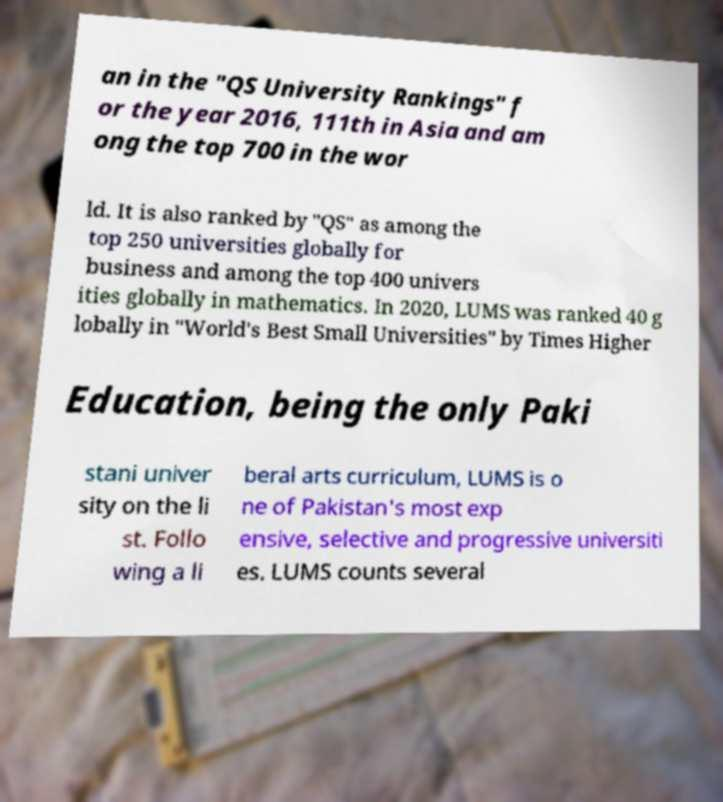What messages or text are displayed in this image? I need them in a readable, typed format. an in the "QS University Rankings" f or the year 2016, 111th in Asia and am ong the top 700 in the wor ld. It is also ranked by "QS" as among the top 250 universities globally for business and among the top 400 univers ities globally in mathematics. In 2020, LUMS was ranked 40 g lobally in "World's Best Small Universities" by Times Higher Education, being the only Paki stani univer sity on the li st. Follo wing a li beral arts curriculum, LUMS is o ne of Pakistan's most exp ensive, selective and progressive universiti es. LUMS counts several 